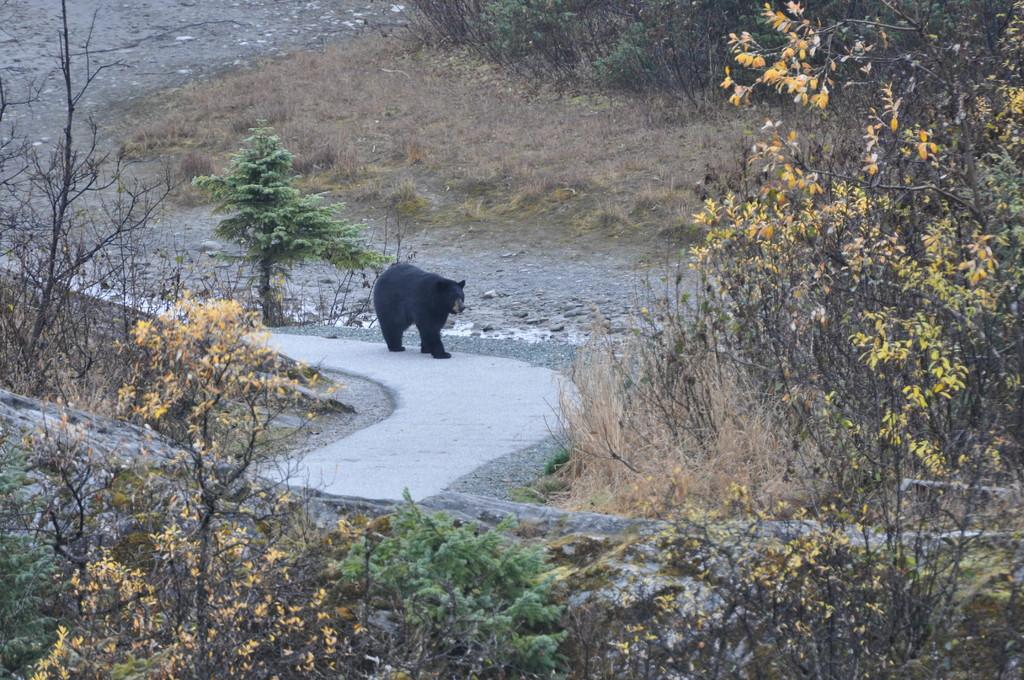What animal is in the image? There is a bear in the image. What is the bear doing in the image? The bear is walking on the road. What can be seen on the right side of the image? Trees are present on the right side of the image. What is the condition of the vegetation in the background of the image? The background of the image contains dry grass. Is the bear an expert in navigating through quicksand in the image? There is no quicksand present in the image, and therefore it cannot be determined if the bear is an expert in navigating through it. 